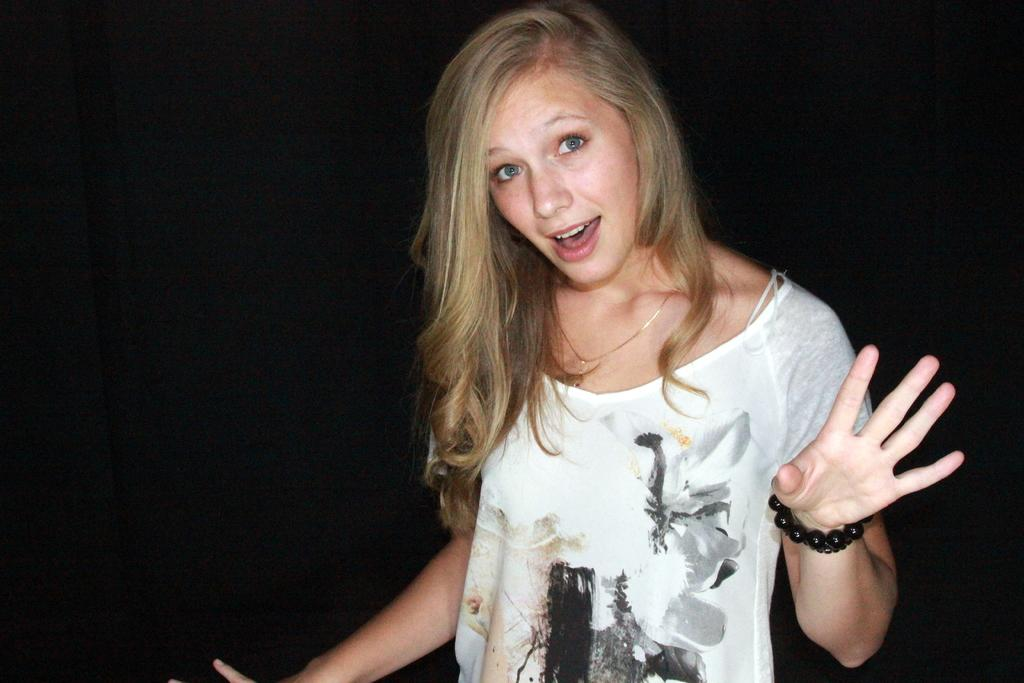Who is the main subject in the image? There is a girl in the image. What is the girl doing in the image? The girl is standing and looking into the camera. What can be observed about the background of the image? The background of the image is dark. What type of horse can be seen sitting on the sofa in the image? There is no horse or sofa present in the image; it features a girl standing and looking into the camera with a dark background. 